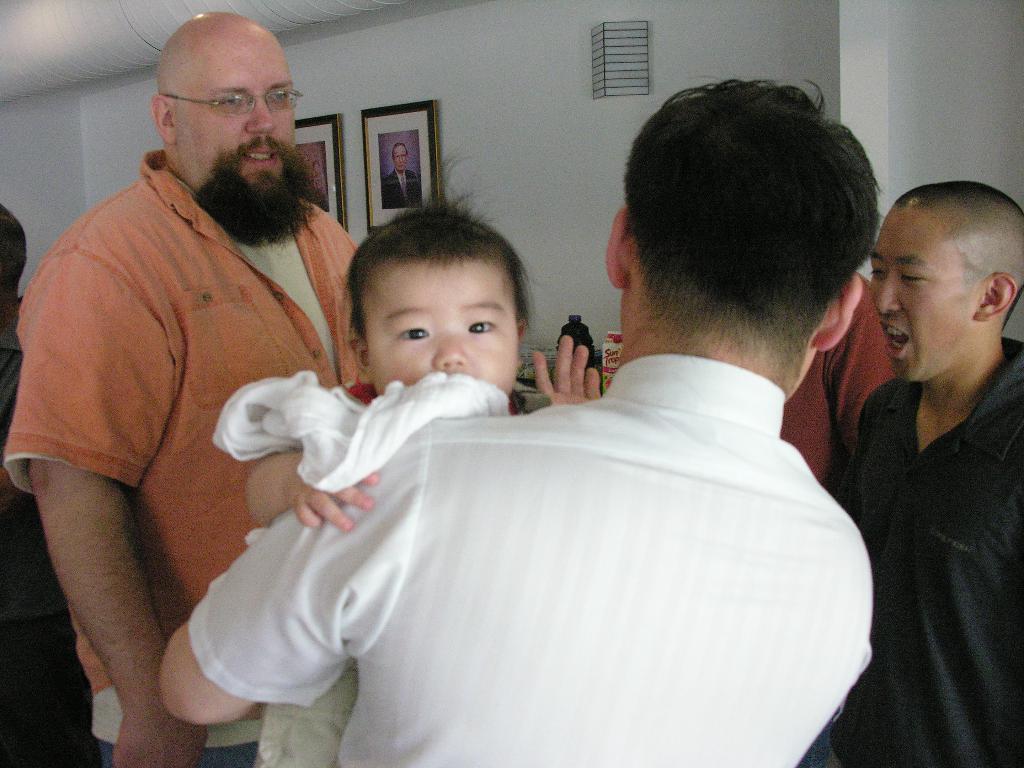Could you give a brief overview of what you see in this image? There is one man holding a baby as we can see at the bottom of this image. We can see people on the left side of this image and is on the right side of this image as well and there is a wall in the background. There are photo frames are attached to it. 